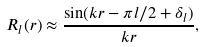<formula> <loc_0><loc_0><loc_500><loc_500>R _ { l } ( r ) \approx \frac { \sin ( k r - \pi l / 2 + \delta _ { l } ) } { k r } ,</formula> 